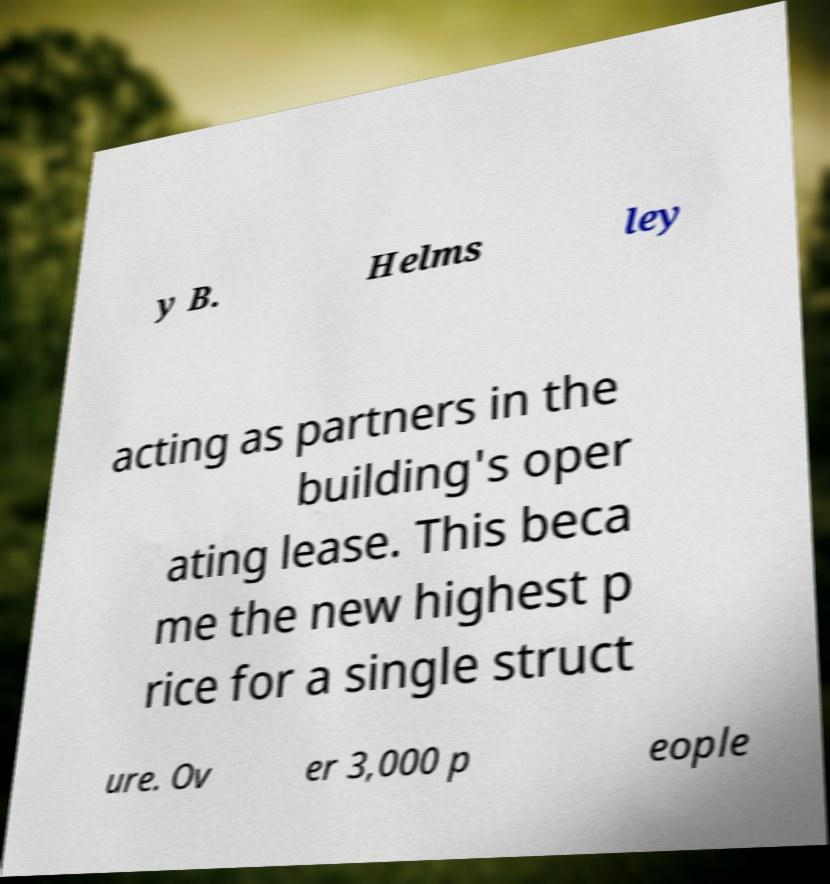For documentation purposes, I need the text within this image transcribed. Could you provide that? y B. Helms ley acting as partners in the building's oper ating lease. This beca me the new highest p rice for a single struct ure. Ov er 3,000 p eople 